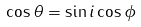<formula> <loc_0><loc_0><loc_500><loc_500>\cos \theta = \sin i \cos \phi</formula> 